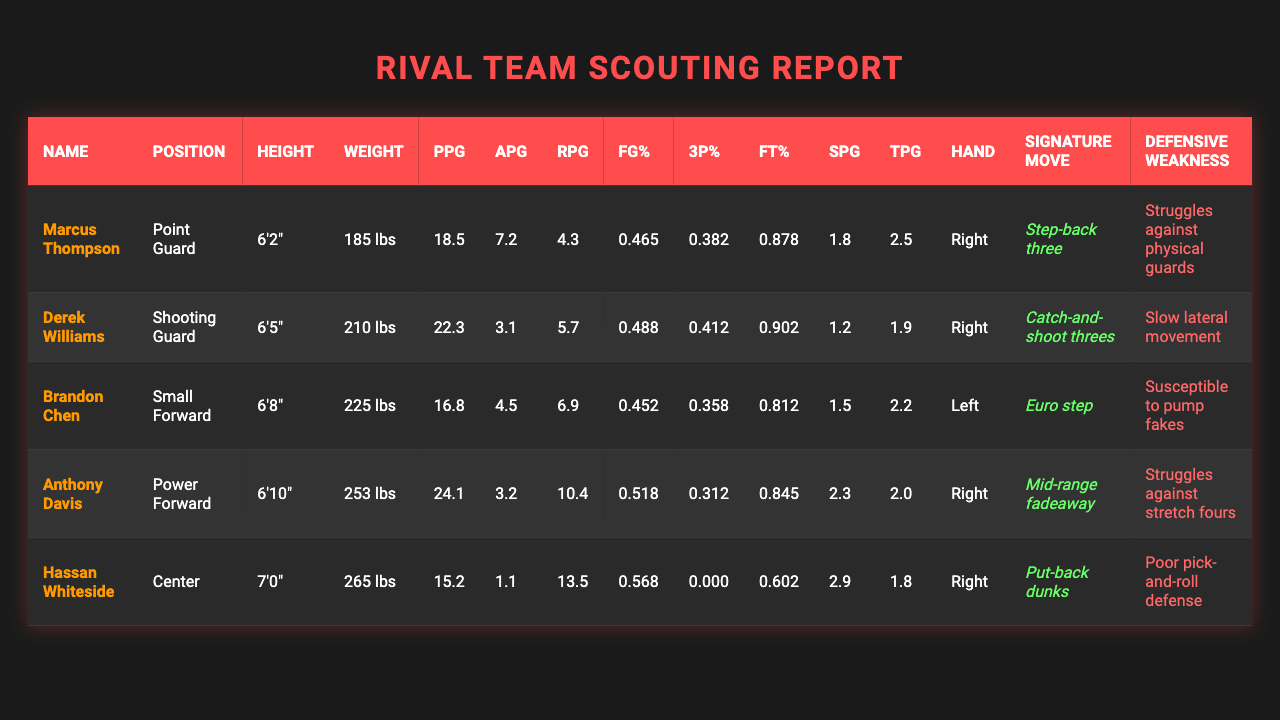What is Marcus Thompson's average points per game (PPG)? According to the table, Marcus Thompson has a PPG of 18.5.
Answer: 18.5 What is the free throw percentage of Anthony Davis? The table indicates that Anthony Davis has a free throw percentage of 0.845.
Answer: 0.845 Which player has the highest rebounds per game (RPG) and what is the value? Checking the RPG values in the table, Hassan Whiteside has the highest with 13.5 RPG.
Answer: 13.5 Is Derek Williams a Shooting Guard? The table shows that Derek Williams is listed under the position of Shooting Guard.
Answer: Yes What is the combined average points per game (PPG) of all players? The PPG values are 18.5, 22.3, 16.8, 24.1, and 15.2. Their sum is 96.9 and there are 5 players, so the average is 96.9/5 = 19.38.
Answer: 19.38 What percentage of players have a three-point shooting percentage (3P%) above 0.400? Only two players, Derek Williams and Marcus Thompson, have a 3P% above 0.400 out of five players. So, 2/5 = 0.4 or 40%.
Answer: 40% How many players have a defensive weakness related to perimeter defense? Reviewing the defensive weaknesses, only one player, Anthony Davis, struggles against stretch fours which is a perimeter issue.
Answer: 1 Who is the tallest player on the team, and what is their height? By checking the height details, Hassan Whiteside is the tallest player at 7'0".
Answer: 7'0" What is the average height of all players on the team? The heights are 6'2", 6'5", 6'8", 6'10", and 7'0". First, convert these to inches (74, 77, 80, 82, 84), summing to 397 inches. Average height = 397/5 = 79.4 inches or 6'7.4".
Answer: 6'7.4" Which player has the lowest turnovers per game (TPG) and what is that value? Assessing the TPG, Hassan Whiteside has the lowest at 1.1.
Answer: 1.1 